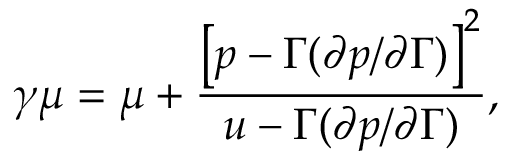Convert formula to latex. <formula><loc_0><loc_0><loc_500><loc_500>\gamma \mu = \mu + \frac { \left [ p - \Gamma ( \partial p / \partial \Gamma ) \right ] ^ { 2 } } { u - \Gamma ( \partial p / \partial \Gamma ) } ,</formula> 